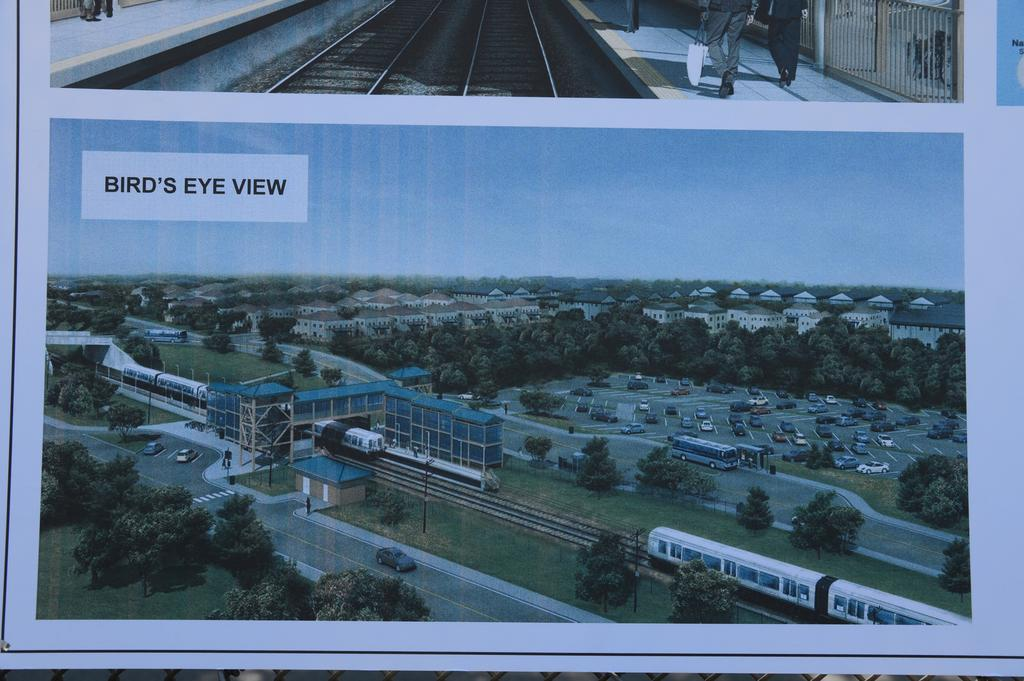What type of images can be seen in the picture? There are pictures in the image. What natural elements are visible in the image? Trees and grass are present in the image. What man-made structures can be seen in the image? Buildings, poles, and roads are visible in the image. What mode of transportation is present in the image? A train is visible in the image. What type of vehicles are present in the image? Vehicles are present in the image. What is the color of the sky in the image? The sky is blue in the image. What might be used for transportation or communication in the image? Tracks and poles are present in the image. What can be seen on the ground in the image? Grass and roads are visible in the image. What is written on the image? Something is written on the image. Can you tell me the name of the lawyer in the image? There is no lawyer present in the image. What type of trail can be seen in the image? There is no trail visible in the image. 